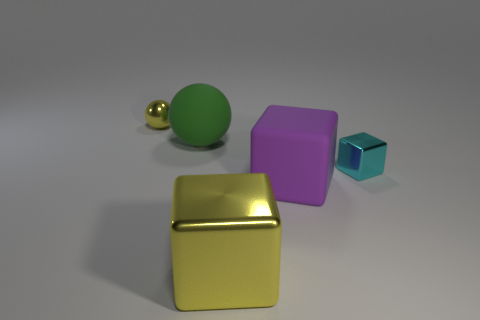Subtract 1 cubes. How many cubes are left? 2 Add 4 tiny purple metal cylinders. How many objects exist? 9 Subtract all blocks. How many objects are left? 2 Add 5 large blocks. How many large blocks exist? 7 Subtract 1 green balls. How many objects are left? 4 Subtract all tiny green matte spheres. Subtract all tiny metal cubes. How many objects are left? 4 Add 2 cyan things. How many cyan things are left? 3 